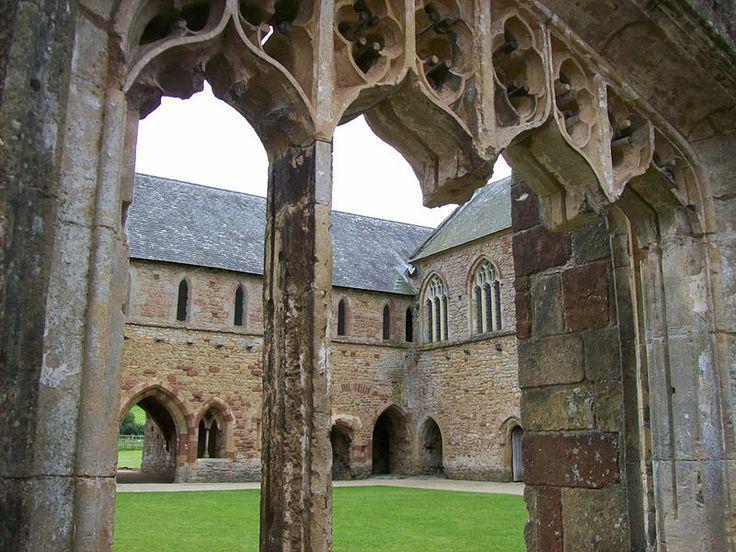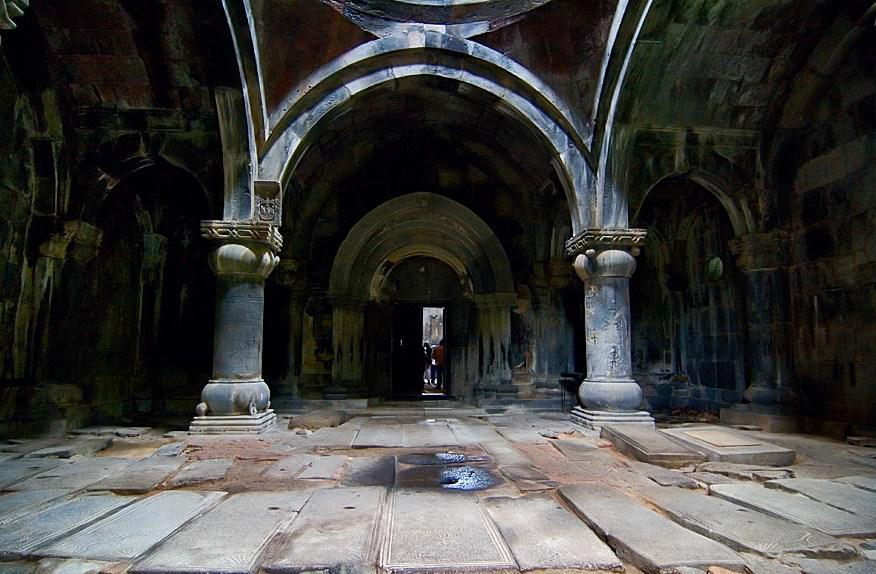The first image is the image on the left, the second image is the image on the right. Evaluate the accuracy of this statement regarding the images: "An image shows green lawn and a view of the outdoors through an archway.". Is it true? Answer yes or no. Yes. The first image is the image on the left, the second image is the image on the right. For the images shown, is this caption "A grassy outdoor area can be seen near the building in the image on the left." true? Answer yes or no. Yes. 